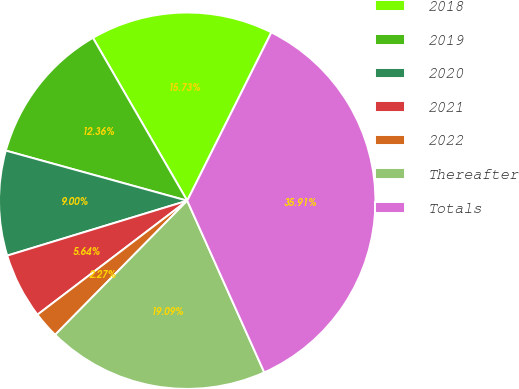<chart> <loc_0><loc_0><loc_500><loc_500><pie_chart><fcel>2018<fcel>2019<fcel>2020<fcel>2021<fcel>2022<fcel>Thereafter<fcel>Totals<nl><fcel>15.73%<fcel>12.36%<fcel>9.0%<fcel>5.64%<fcel>2.27%<fcel>19.09%<fcel>35.91%<nl></chart> 